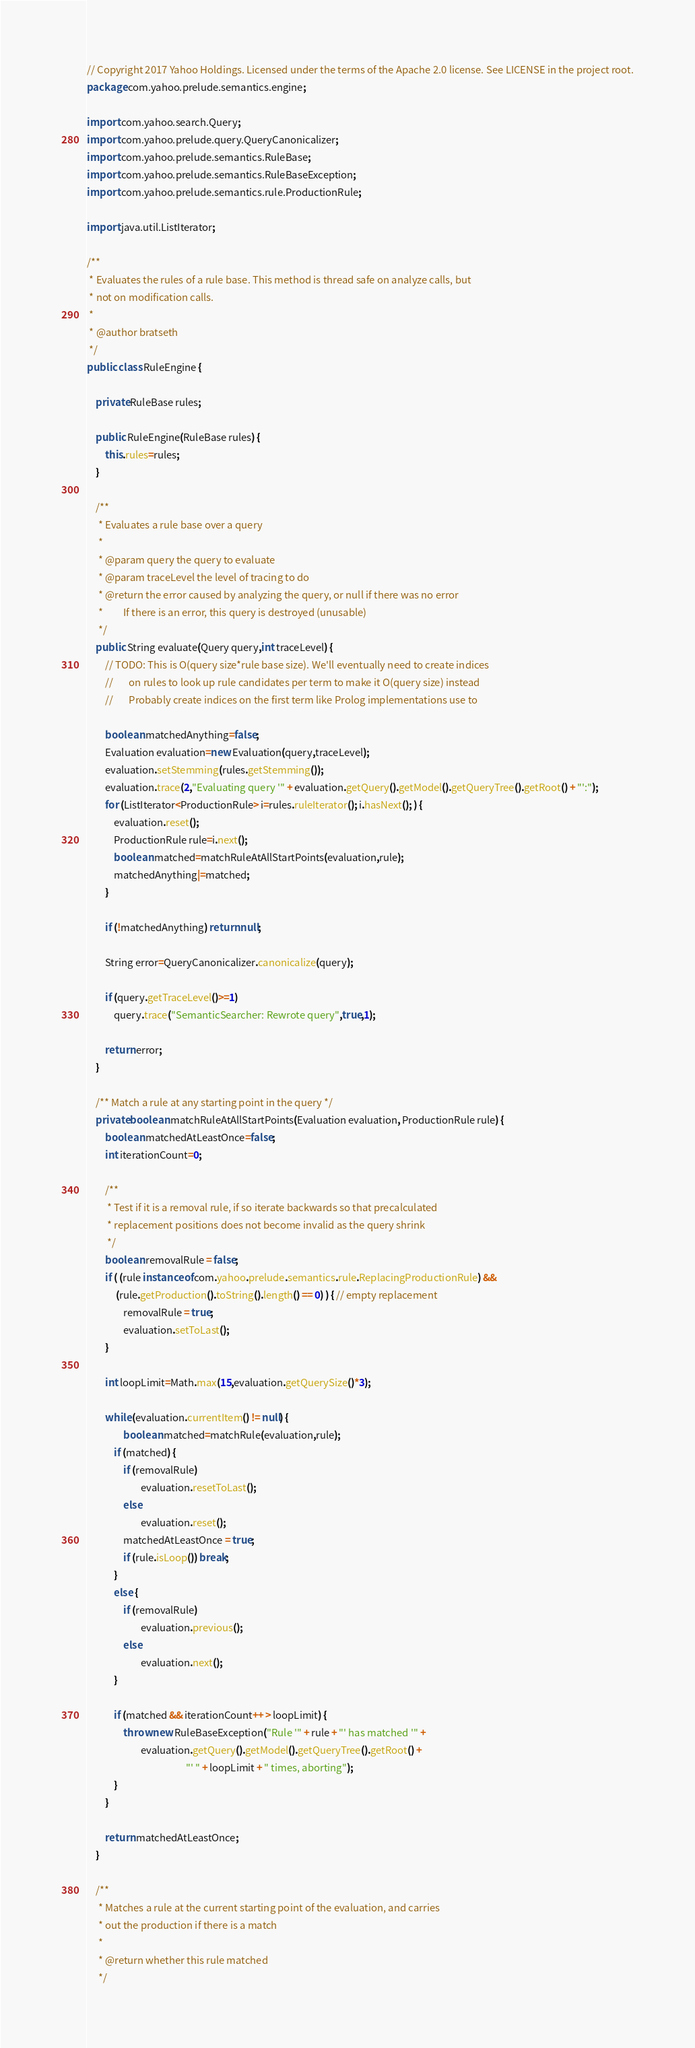<code> <loc_0><loc_0><loc_500><loc_500><_Java_>// Copyright 2017 Yahoo Holdings. Licensed under the terms of the Apache 2.0 license. See LICENSE in the project root.
package com.yahoo.prelude.semantics.engine;

import com.yahoo.search.Query;
import com.yahoo.prelude.query.QueryCanonicalizer;
import com.yahoo.prelude.semantics.RuleBase;
import com.yahoo.prelude.semantics.RuleBaseException;
import com.yahoo.prelude.semantics.rule.ProductionRule;

import java.util.ListIterator;

/**
 * Evaluates the rules of a rule base. This method is thread safe on analyze calls, but
 * not on modification calls.
 *
 * @author bratseth
 */
public class RuleEngine {

    private RuleBase rules;

    public RuleEngine(RuleBase rules) {
        this.rules=rules;
    }

    /**
     * Evaluates a rule base over a query
     *
     * @param query the query to evaluate
     * @param traceLevel the level of tracing to do
     * @return the error caused by analyzing the query, or null if there was no error
     *         If there is an error, this query is destroyed (unusable)
     */
    public String evaluate(Query query,int traceLevel) {
        // TODO: This is O(query size*rule base size). We'll eventually need to create indices
        //       on rules to look up rule candidates per term to make it O(query size) instead
        //       Probably create indices on the first term like Prolog implementations use to

        boolean matchedAnything=false;
        Evaluation evaluation=new Evaluation(query,traceLevel);
        evaluation.setStemming(rules.getStemming());
        evaluation.trace(2,"Evaluating query '" + evaluation.getQuery().getModel().getQueryTree().getRoot() + "':");
        for (ListIterator<ProductionRule> i=rules.ruleIterator(); i.hasNext(); ) {
            evaluation.reset();
            ProductionRule rule=i.next();
            boolean matched=matchRuleAtAllStartPoints(evaluation,rule);
            matchedAnything|=matched;
        }

        if (!matchedAnything) return null;

        String error=QueryCanonicalizer.canonicalize(query);

        if (query.getTraceLevel()>=1)
            query.trace("SemanticSearcher: Rewrote query",true,1);

        return error;
    }

    /** Match a rule at any starting point in the query */
    private boolean matchRuleAtAllStartPoints(Evaluation evaluation, ProductionRule rule) {
        boolean matchedAtLeastOnce=false;
        int iterationCount=0;

        /**
         * Test if it is a removal rule, if so iterate backwards so that precalculated
         * replacement positions does not become invalid as the query shrink
         */
        boolean removalRule = false;
        if ( (rule instanceof com.yahoo.prelude.semantics.rule.ReplacingProductionRule) &&
             (rule.getProduction().toString().length() == 0) ) { // empty replacement
                removalRule = true;
                evaluation.setToLast();
        }

        int loopLimit=Math.max(15,evaluation.getQuerySize()*3);

        while (evaluation.currentItem() != null) {
                boolean matched=matchRule(evaluation,rule);
            if (matched) {
                if (removalRule)
                        evaluation.resetToLast();
                else
                        evaluation.reset();
                matchedAtLeastOnce = true;
                if (rule.isLoop()) break;
            }
            else {
                if (removalRule)
                        evaluation.previous();
                else
                        evaluation.next();
            }

            if (matched && iterationCount++ > loopLimit) {
                throw new RuleBaseException("Rule '" + rule + "' has matched '" +
                        evaluation.getQuery().getModel().getQueryTree().getRoot() +
                                            "' " + loopLimit + " times, aborting");
            }
        }

        return matchedAtLeastOnce;
    }

    /**
     * Matches a rule at the current starting point of the evaluation, and carries
     * out the production if there is a match
     *
     * @return whether this rule matched
     */</code> 